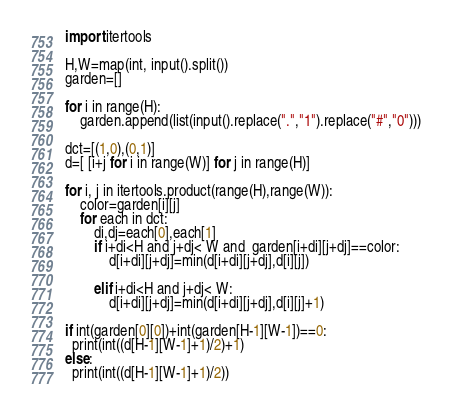Convert code to text. <code><loc_0><loc_0><loc_500><loc_500><_Python_>import itertools
 
H,W=map(int, input().split())
garden=[]
 
for i in range(H):
    garden.append(list(input().replace(".","1").replace("#","0")))
 
dct=[(1,0),(0,1)]
d=[ [i+j for i in range(W)] for j in range(H)]

for i, j in itertools.product(range(H),range(W)):
    color=garden[i][j]
    for each in dct:
        di,dj=each[0],each[1]
        if i+di<H and j+dj< W and  garden[i+di][j+dj]==color:
            d[i+di][j+dj]=min(d[i+di][j+dj],d[i][j])

        elif i+di<H and j+dj< W:
            d[i+di][j+dj]=min(d[i+di][j+dj],d[i][j]+1)

if int(garden[0][0])+int(garden[H-1][W-1])==0:
  print(int((d[H-1][W-1]+1)/2)+1)
else:
  print(int((d[H-1][W-1]+1)/2))</code> 